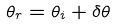<formula> <loc_0><loc_0><loc_500><loc_500>\theta _ { r } = \theta _ { i } + \delta \theta</formula> 